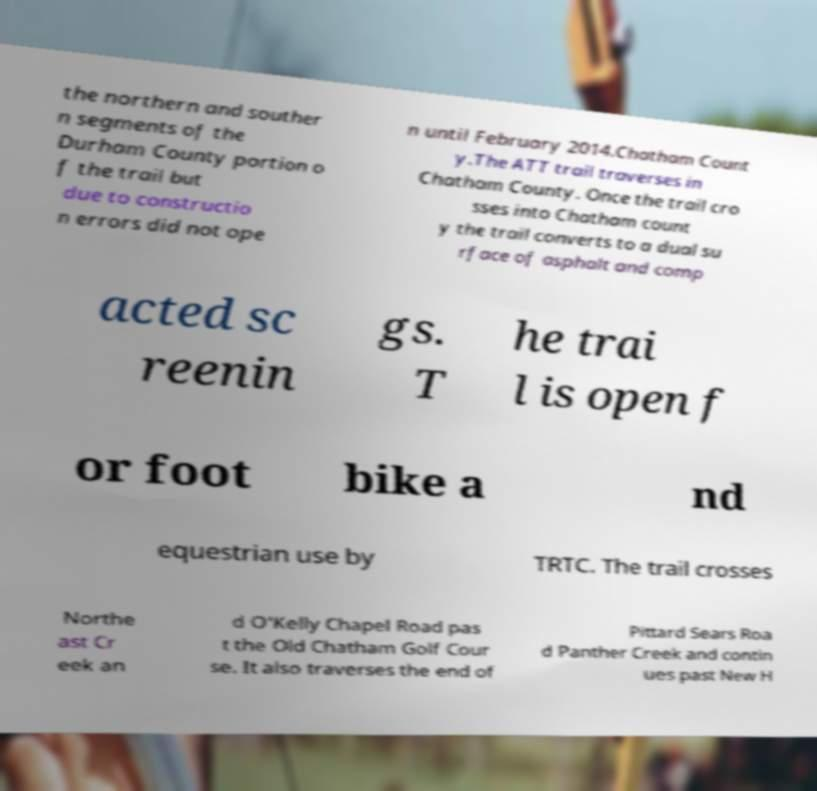For documentation purposes, I need the text within this image transcribed. Could you provide that? the northern and souther n segments of the Durham County portion o f the trail but due to constructio n errors did not ope n until February 2014.Chatham Count y.The ATT trail traverses in Chatham County. Once the trail cro sses into Chatham count y the trail converts to a dual su rface of asphalt and comp acted sc reenin gs. T he trai l is open f or foot bike a nd equestrian use by TRTC. The trail crosses Northe ast Cr eek an d O'Kelly Chapel Road pas t the Old Chatham Golf Cour se. It also traverses the end of Pittard Sears Roa d Panther Creek and contin ues past New H 